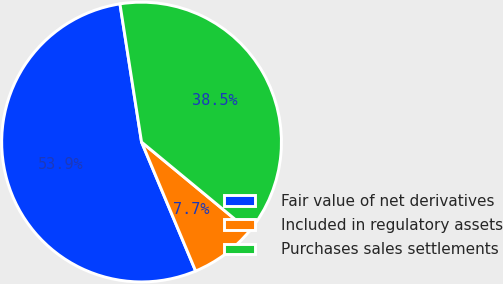<chart> <loc_0><loc_0><loc_500><loc_500><pie_chart><fcel>Fair value of net derivatives<fcel>Included in regulatory assets<fcel>Purchases sales settlements<nl><fcel>53.85%<fcel>7.69%<fcel>38.46%<nl></chart> 